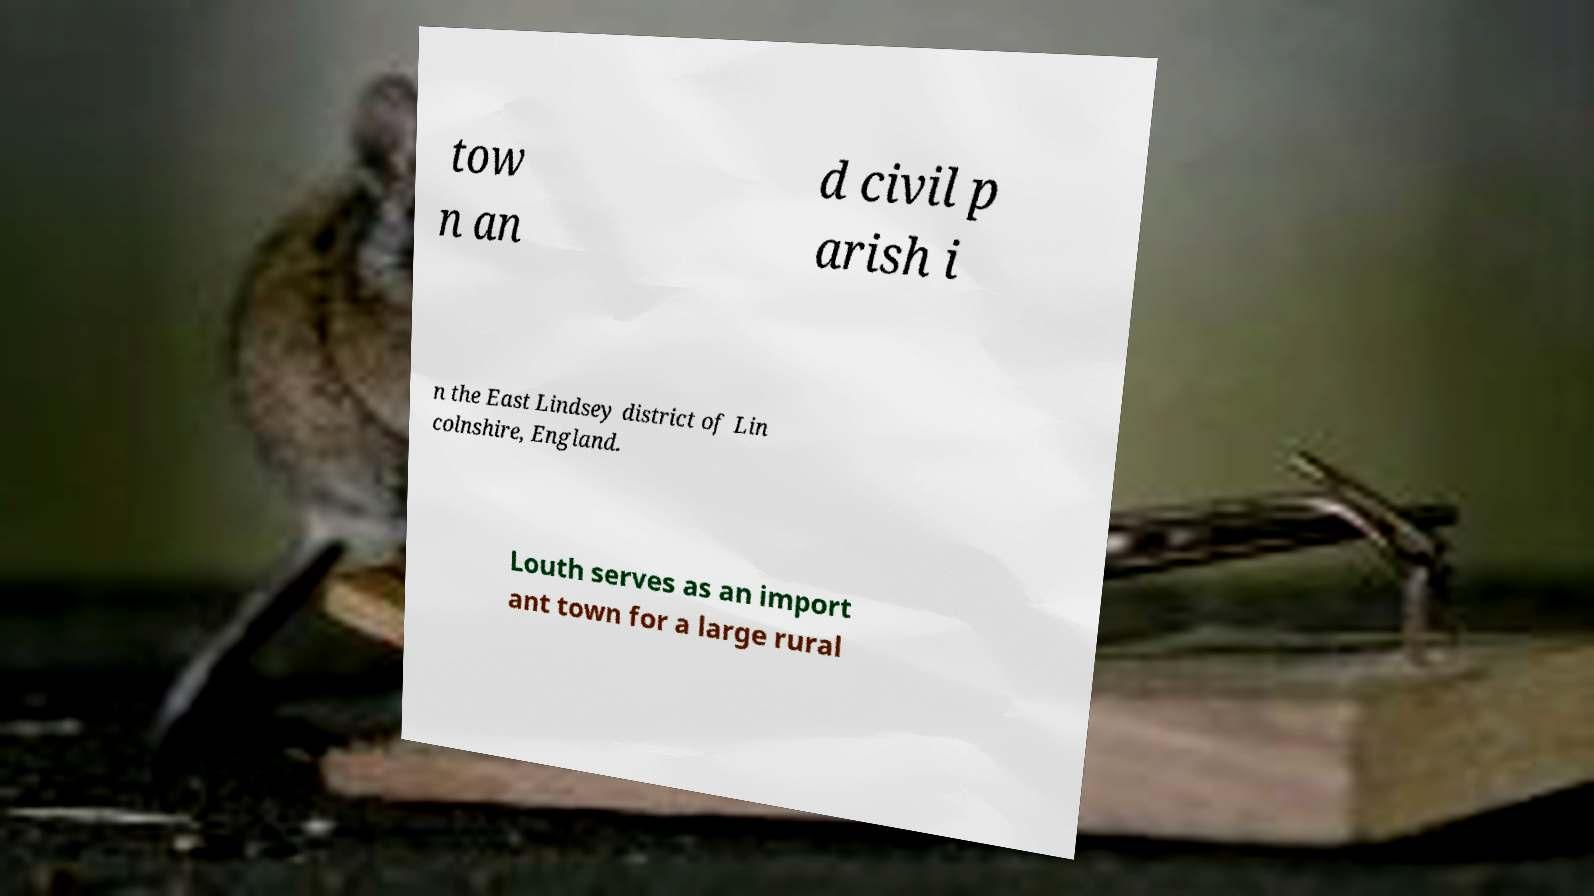Please identify and transcribe the text found in this image. tow n an d civil p arish i n the East Lindsey district of Lin colnshire, England. Louth serves as an import ant town for a large rural 